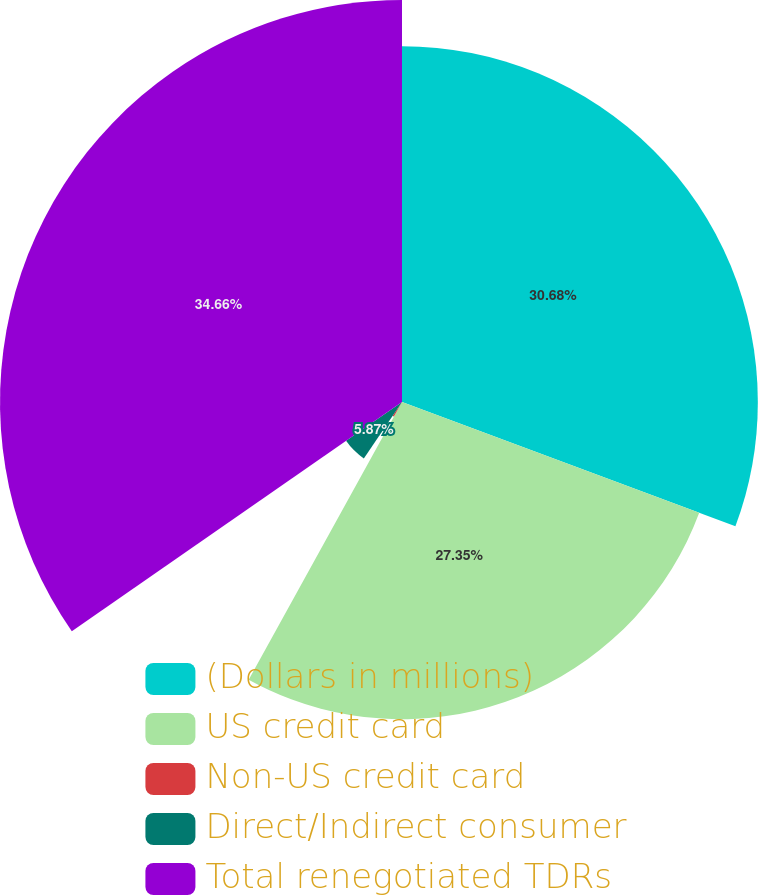<chart> <loc_0><loc_0><loc_500><loc_500><pie_chart><fcel>(Dollars in millions)<fcel>US credit card<fcel>Non-US credit card<fcel>Direct/Indirect consumer<fcel>Total renegotiated TDRs<nl><fcel>30.68%<fcel>27.35%<fcel>1.44%<fcel>5.87%<fcel>34.66%<nl></chart> 